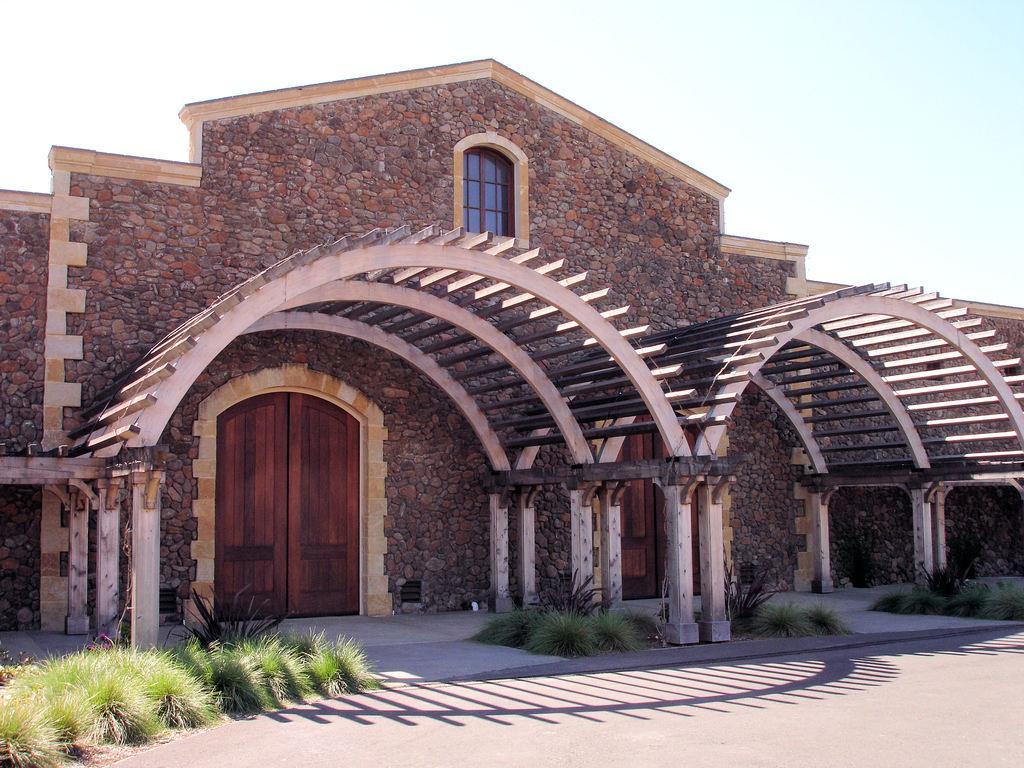Describe this image in one or two sentences. In this picture we can see a house, in front of the house we can find few plants. 